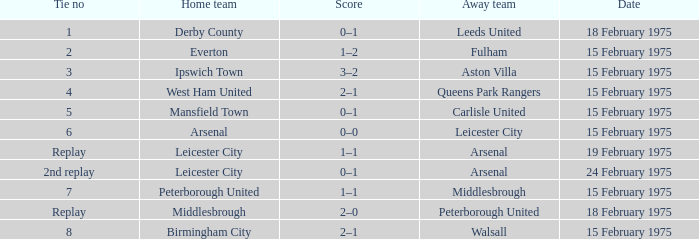What was the date when the visiting team was leeds united? 18 February 1975. 